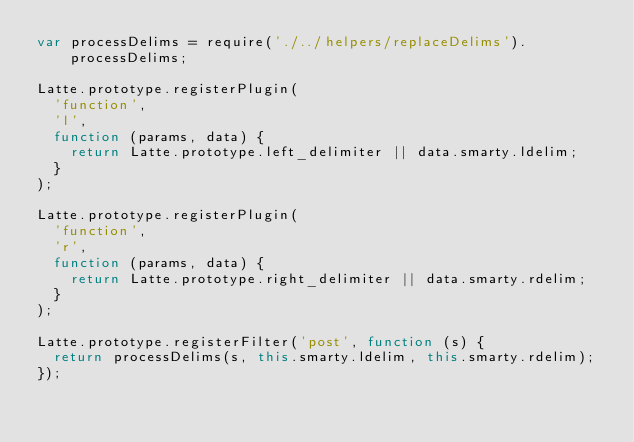Convert code to text. <code><loc_0><loc_0><loc_500><loc_500><_JavaScript_>var processDelims = require('./../helpers/replaceDelims').processDelims;

Latte.prototype.registerPlugin(
  'function',
  'l',
  function (params, data) {
    return Latte.prototype.left_delimiter || data.smarty.ldelim;
  }
);

Latte.prototype.registerPlugin(
  'function',
  'r',
  function (params, data) {
    return Latte.prototype.right_delimiter || data.smarty.rdelim;
  }
);

Latte.prototype.registerFilter('post', function (s) {
  return processDelims(s, this.smarty.ldelim, this.smarty.rdelim);
});
</code> 